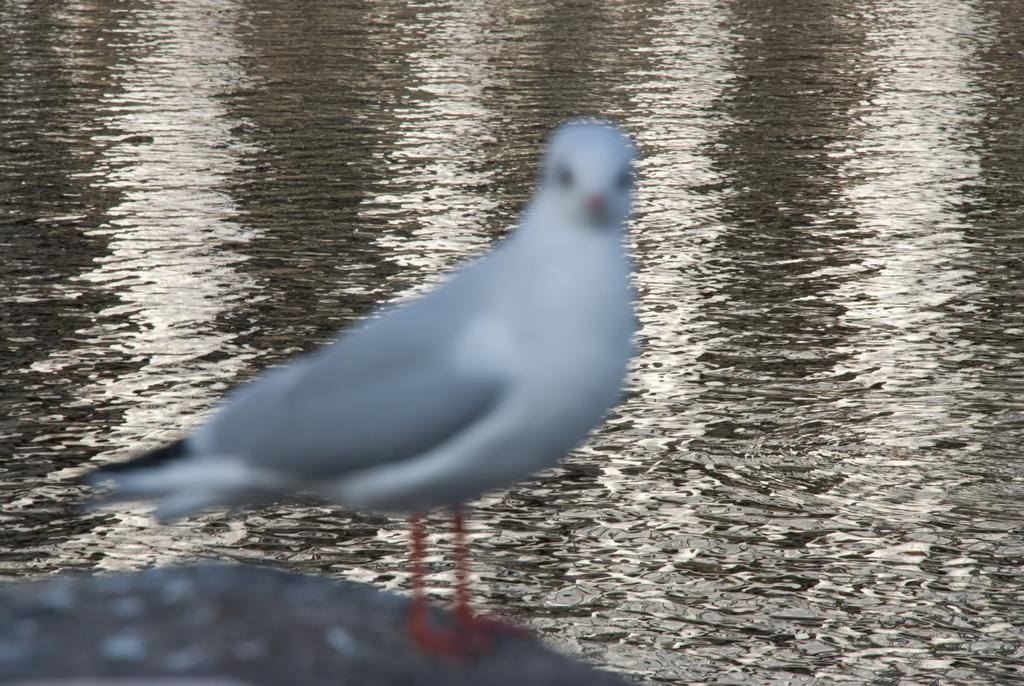Where was the picture taken? The picture was clicked outside. What can be seen in the foreground of the image? There is a bird in the foreground of the image. What is the bird doing in the image? The bird appears to be standing on the ground. What can be seen in the background of the image? There is a water body visible in the background of the image. What type of reward is the bird holding in its foot in the image? There is no reward visible in the image, and the bird is not holding anything in its foot. 